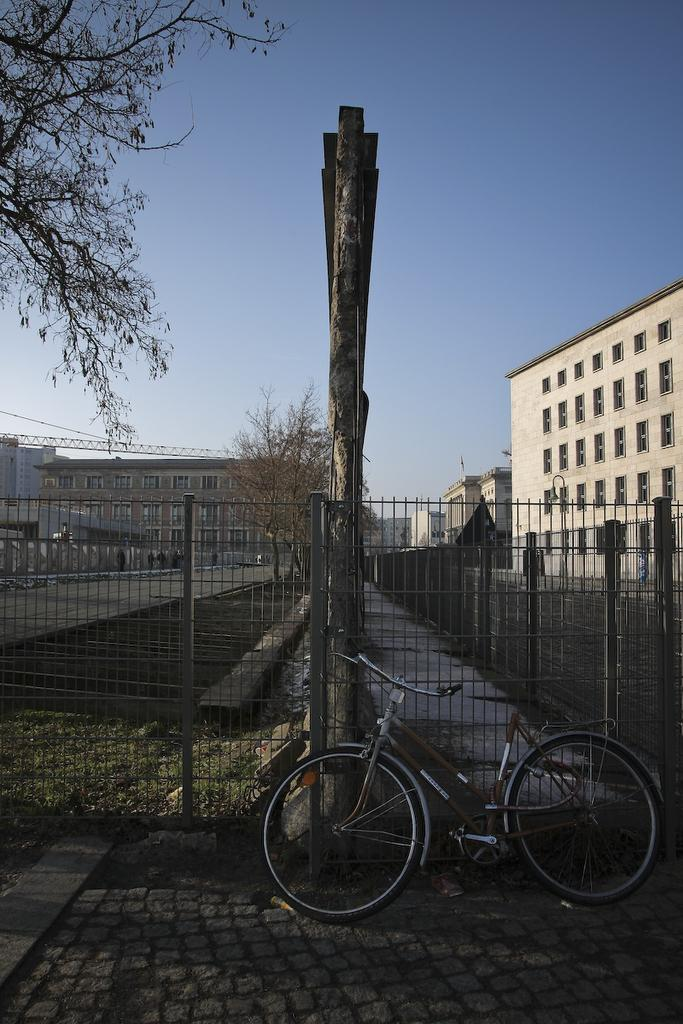What type of surface can be seen in the image? There is ground visible in the image. What mode of transportation is present in the image? There is a bicycle in the image. What type of barrier is in the image? There is metal fencing in the image. What is the wooden object in the image? There is a wooden pole in the image. What type of vegetation is in the image? There are trees in the image. What structures can be seen in the background of the image? There are buildings in the background of the image. What part of the natural environment is visible in the background of the image? The sky is visible in the background of the image. What fact is being discussed by the trees in the image? There is no discussion or fact being presented by the trees in the image; they are simply vegetation. 